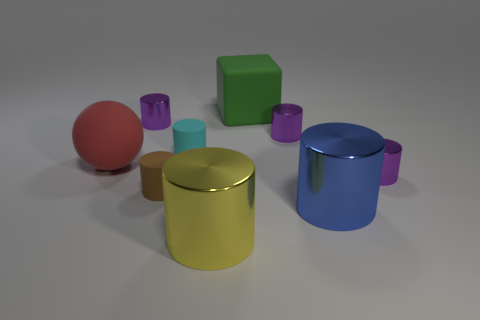What is the size of the matte thing that is in front of the large matte ball left of the tiny brown object?
Provide a succinct answer. Small. Is the tiny purple cylinder that is in front of the red rubber sphere made of the same material as the big blue cylinder?
Keep it short and to the point. Yes. There is a small purple thing that is right of the big blue shiny cylinder; what shape is it?
Your answer should be compact. Cylinder. How many brown matte things are the same size as the cyan cylinder?
Ensure brevity in your answer.  1. What size is the cyan object?
Give a very brief answer. Small. There is a green thing; what number of metallic cylinders are left of it?
Your answer should be compact. 2. There is another large thing that is the same material as the red thing; what shape is it?
Ensure brevity in your answer.  Cube. Are there fewer large blocks left of the green block than brown matte things behind the large red sphere?
Make the answer very short. No. Is the number of tiny purple metal objects greater than the number of cylinders?
Offer a terse response. No. What material is the green thing?
Your response must be concise. Rubber. 